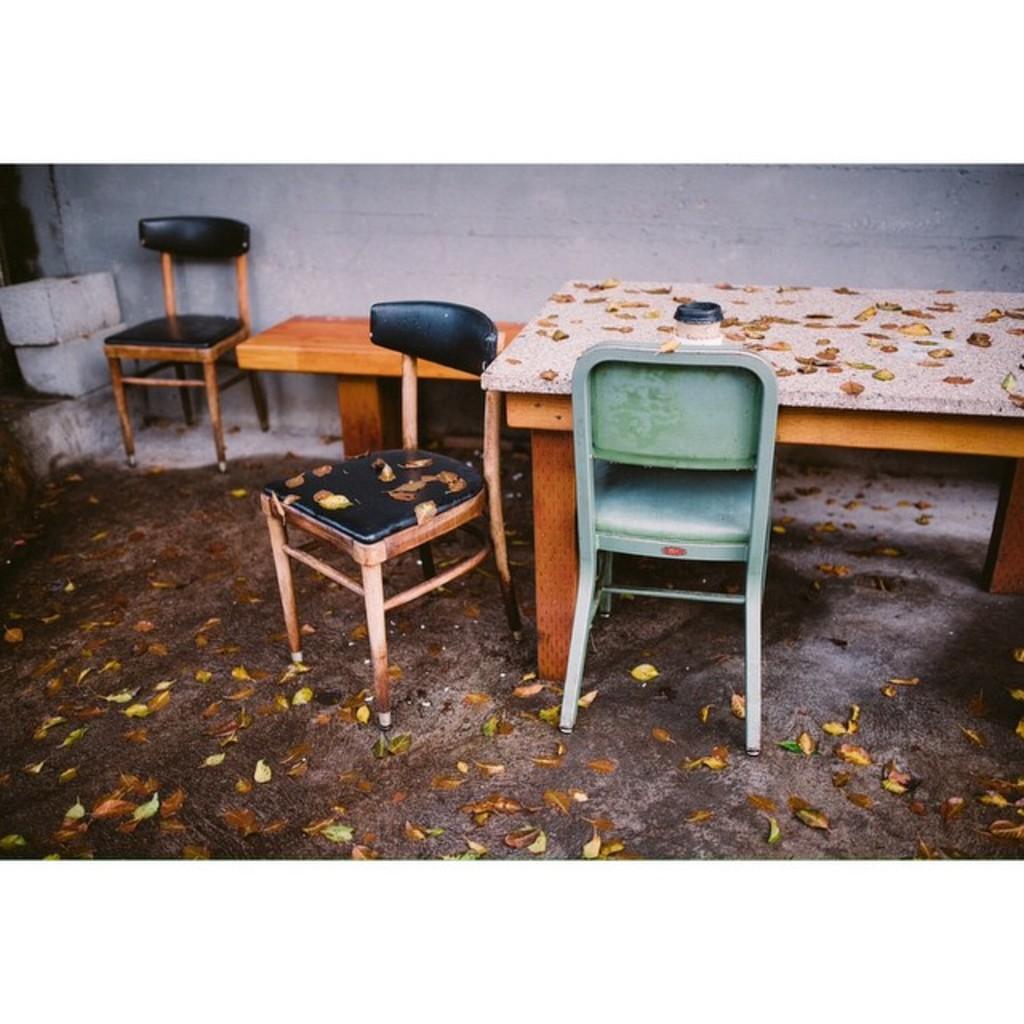Describe this image in one or two sentences. In this image we can see the chairs, table and a bench, there are bricks and leaves on the ground, in the background, we can see the wall. 